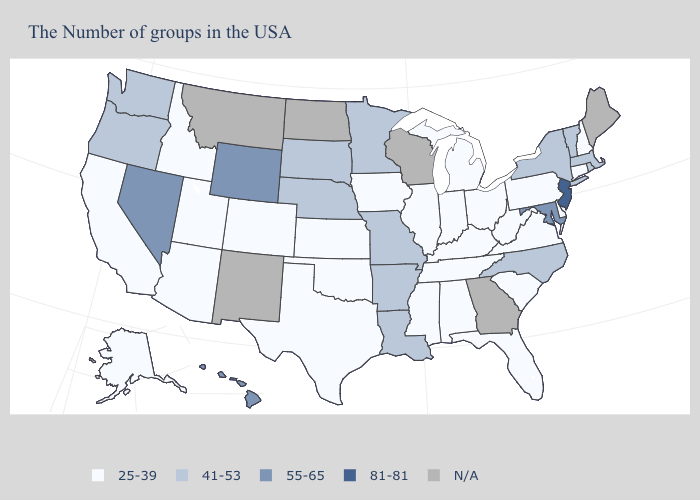What is the value of Nebraska?
Quick response, please. 41-53. Which states have the lowest value in the USA?
Quick response, please. New Hampshire, Connecticut, Delaware, Pennsylvania, Virginia, South Carolina, West Virginia, Ohio, Florida, Michigan, Kentucky, Indiana, Alabama, Tennessee, Illinois, Mississippi, Iowa, Kansas, Oklahoma, Texas, Colorado, Utah, Arizona, Idaho, California, Alaska. Does Kansas have the highest value in the USA?
Keep it brief. No. What is the highest value in the USA?
Be succinct. 81-81. Does Wyoming have the highest value in the West?
Short answer required. Yes. Name the states that have a value in the range 55-65?
Quick response, please. Maryland, Wyoming, Nevada, Hawaii. What is the value of Michigan?
Answer briefly. 25-39. Name the states that have a value in the range 81-81?
Write a very short answer. New Jersey. Does the first symbol in the legend represent the smallest category?
Answer briefly. Yes. Name the states that have a value in the range 55-65?
Keep it brief. Maryland, Wyoming, Nevada, Hawaii. Does Kansas have the highest value in the USA?
Quick response, please. No. Name the states that have a value in the range 41-53?
Answer briefly. Massachusetts, Rhode Island, Vermont, New York, North Carolina, Louisiana, Missouri, Arkansas, Minnesota, Nebraska, South Dakota, Washington, Oregon. Does Indiana have the lowest value in the USA?
Keep it brief. Yes. Does Pennsylvania have the lowest value in the Northeast?
Quick response, please. Yes. 